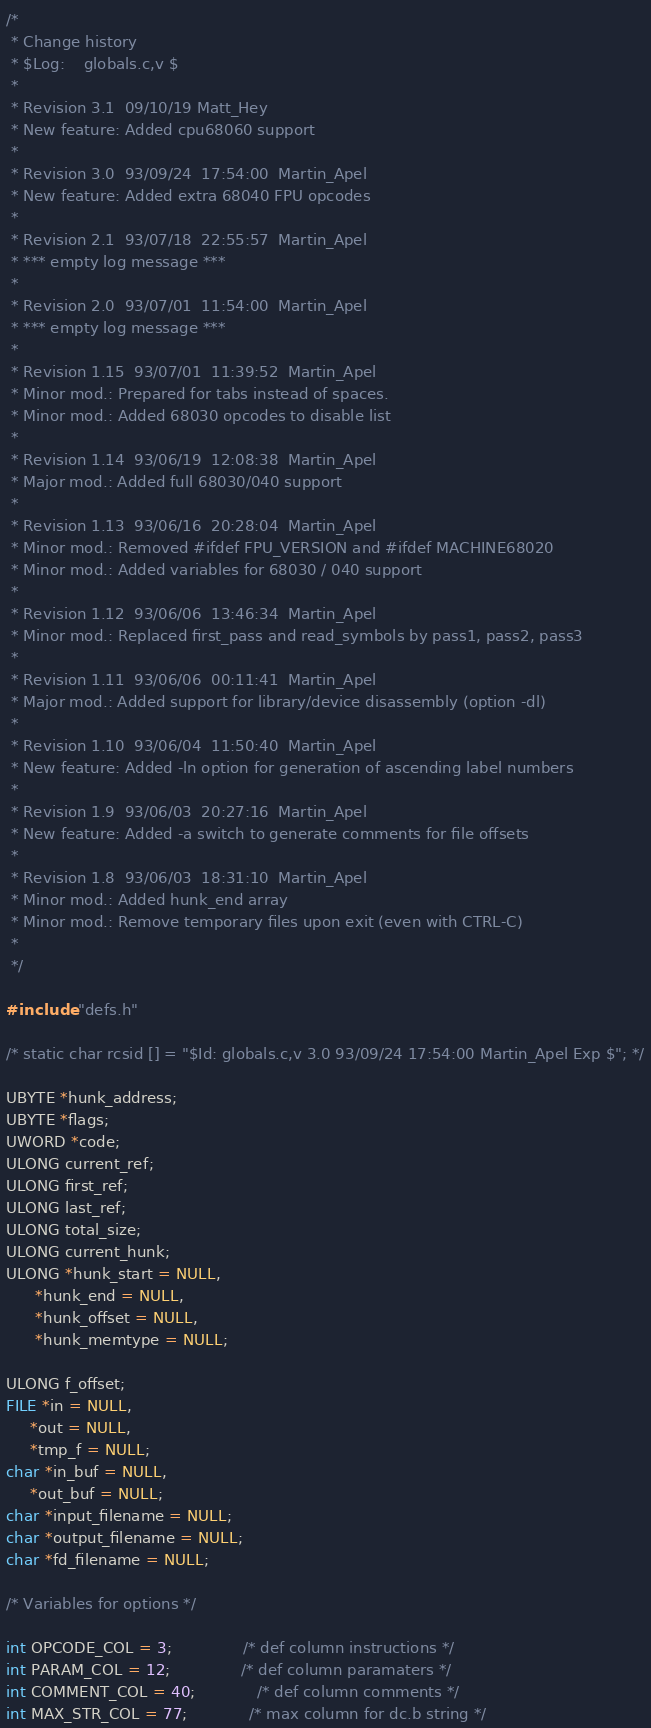<code> <loc_0><loc_0><loc_500><loc_500><_C_>/*
 * Change history
 * $Log:	globals.c,v $
 *
 * Revision 3.1  09/10/19 Matt_Hey
 * New feature: Added cpu68060 support
 *
 * Revision 3.0  93/09/24  17:54:00  Martin_Apel
 * New feature: Added extra 68040 FPU opcodes
 * 
 * Revision 2.1  93/07/18  22:55:57  Martin_Apel
 * *** empty log message ***
 * 
 * Revision 2.0  93/07/01  11:54:00  Martin_Apel
 * *** empty log message ***
 * 
 * Revision 1.15  93/07/01  11:39:52  Martin_Apel
 * Minor mod.: Prepared for tabs instead of spaces.
 * Minor mod.: Added 68030 opcodes to disable list
 * 
 * Revision 1.14  93/06/19  12:08:38  Martin_Apel
 * Major mod.: Added full 68030/040 support
 * 
 * Revision 1.13  93/06/16  20:28:04  Martin_Apel
 * Minor mod.: Removed #ifdef FPU_VERSION and #ifdef MACHINE68020
 * Minor mod.: Added variables for 68030 / 040 support
 * 
 * Revision 1.12  93/06/06  13:46:34  Martin_Apel
 * Minor mod.: Replaced first_pass and read_symbols by pass1, pass2, pass3
 * 
 * Revision 1.11  93/06/06  00:11:41  Martin_Apel
 * Major mod.: Added support for library/device disassembly (option -dl)
 * 
 * Revision 1.10  93/06/04  11:50:40  Martin_Apel
 * New feature: Added -ln option for generation of ascending label numbers
 * 
 * Revision 1.9  93/06/03  20:27:16  Martin_Apel
 * New feature: Added -a switch to generate comments for file offsets
 * 
 * Revision 1.8  93/06/03  18:31:10  Martin_Apel
 * Minor mod.: Added hunk_end array
 * Minor mod.: Remove temporary files upon exit (even with CTRL-C)
 * 
 */

#include "defs.h"

/* static char rcsid [] = "$Id: globals.c,v 3.0 93/09/24 17:54:00 Martin_Apel Exp $"; */

UBYTE *hunk_address;
UBYTE *flags;
UWORD *code;
ULONG current_ref;
ULONG first_ref;
ULONG last_ref;
ULONG total_size;
ULONG current_hunk;
ULONG *hunk_start = NULL,
      *hunk_end = NULL,
      *hunk_offset = NULL,
      *hunk_memtype = NULL;

ULONG f_offset;
FILE *in = NULL,
     *out = NULL,
     *tmp_f = NULL;
char *in_buf = NULL,
     *out_buf = NULL;
char *input_filename = NULL;
char *output_filename = NULL;
char *fd_filename = NULL;

/* Variables for options */

int OPCODE_COL = 3;               /* def column instructions */
int PARAM_COL = 12;               /* def column paramaters */
int COMMENT_COL = 40;             /* def column comments */
int MAX_STR_COL = 77;             /* max column for dc.b string */
</code> 